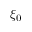<formula> <loc_0><loc_0><loc_500><loc_500>\xi _ { 0 }</formula> 